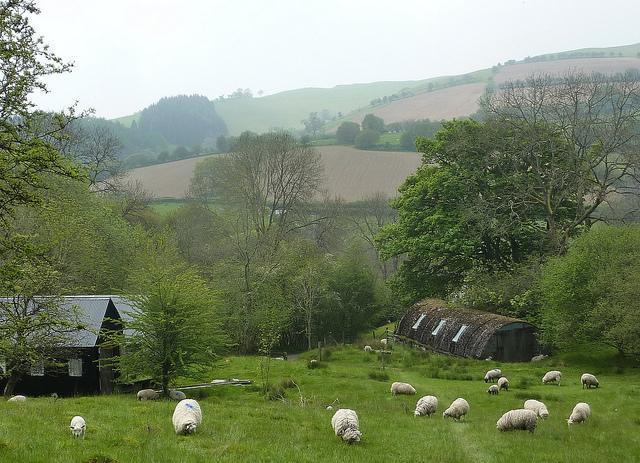How many people are in this image?
Give a very brief answer. 0. 